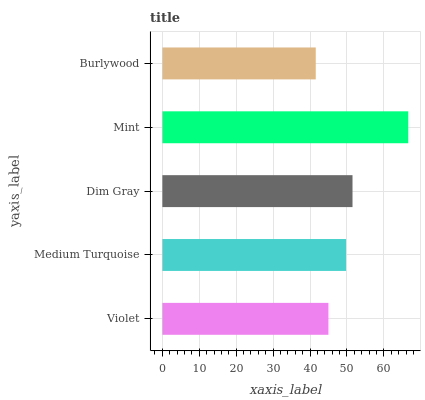Is Burlywood the minimum?
Answer yes or no. Yes. Is Mint the maximum?
Answer yes or no. Yes. Is Medium Turquoise the minimum?
Answer yes or no. No. Is Medium Turquoise the maximum?
Answer yes or no. No. Is Medium Turquoise greater than Violet?
Answer yes or no. Yes. Is Violet less than Medium Turquoise?
Answer yes or no. Yes. Is Violet greater than Medium Turquoise?
Answer yes or no. No. Is Medium Turquoise less than Violet?
Answer yes or no. No. Is Medium Turquoise the high median?
Answer yes or no. Yes. Is Medium Turquoise the low median?
Answer yes or no. Yes. Is Dim Gray the high median?
Answer yes or no. No. Is Mint the low median?
Answer yes or no. No. 